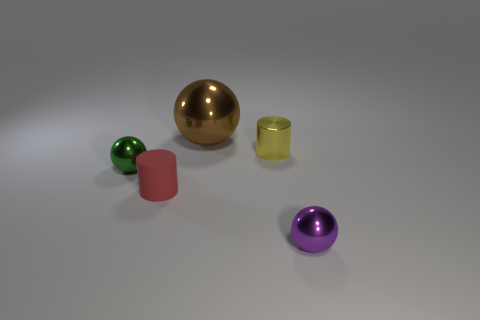Does the small green ball have the same material as the big thing?
Your answer should be very brief. Yes. There is a tiny ball to the right of the thing that is behind the tiny yellow metallic thing; what is its color?
Provide a short and direct response. Purple. There is a green ball that is the same material as the small purple object; what size is it?
Your answer should be compact. Small. How many other things have the same shape as the small matte object?
Make the answer very short. 1. How many objects are either metal things that are in front of the brown metal object or things right of the red thing?
Offer a terse response. 4. How many big brown shiny things are on the right side of the thing to the left of the small matte cylinder?
Your answer should be very brief. 1. Is the shape of the thing behind the metallic cylinder the same as the small metal thing that is to the right of the small yellow shiny thing?
Your answer should be very brief. Yes. Are there any brown objects that have the same material as the tiny red thing?
Your response must be concise. No. What number of metal things are green things or tiny yellow objects?
Offer a very short reply. 2. What shape is the metal thing that is to the left of the ball that is behind the tiny green shiny sphere?
Keep it short and to the point. Sphere. 